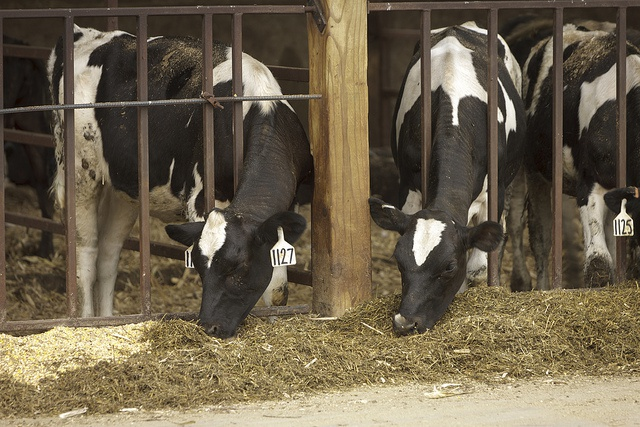Describe the objects in this image and their specific colors. I can see cow in black and gray tones, cow in black, gray, and ivory tones, cow in black, gray, and darkgray tones, and cow in black and gray tones in this image. 